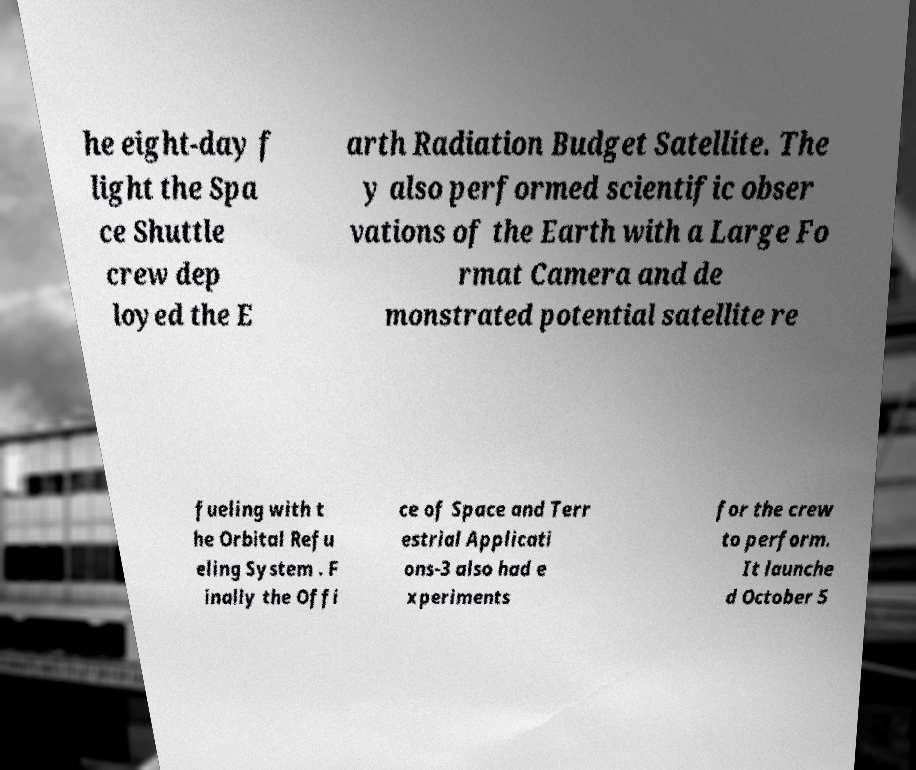Can you accurately transcribe the text from the provided image for me? he eight-day f light the Spa ce Shuttle crew dep loyed the E arth Radiation Budget Satellite. The y also performed scientific obser vations of the Earth with a Large Fo rmat Camera and de monstrated potential satellite re fueling with t he Orbital Refu eling System . F inally the Offi ce of Space and Terr estrial Applicati ons-3 also had e xperiments for the crew to perform. It launche d October 5 